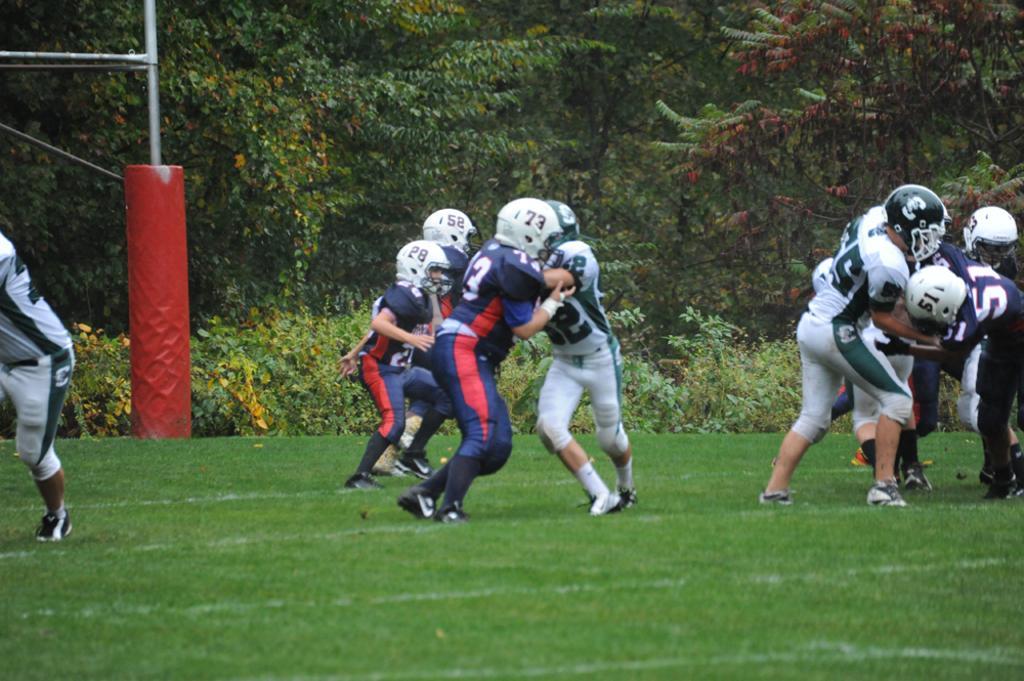How would you summarize this image in a sentence or two? In this image there are people playing game wearing helmets. At the bottom of the image there is grass. In the background of the image there are trees. There is a pole. 